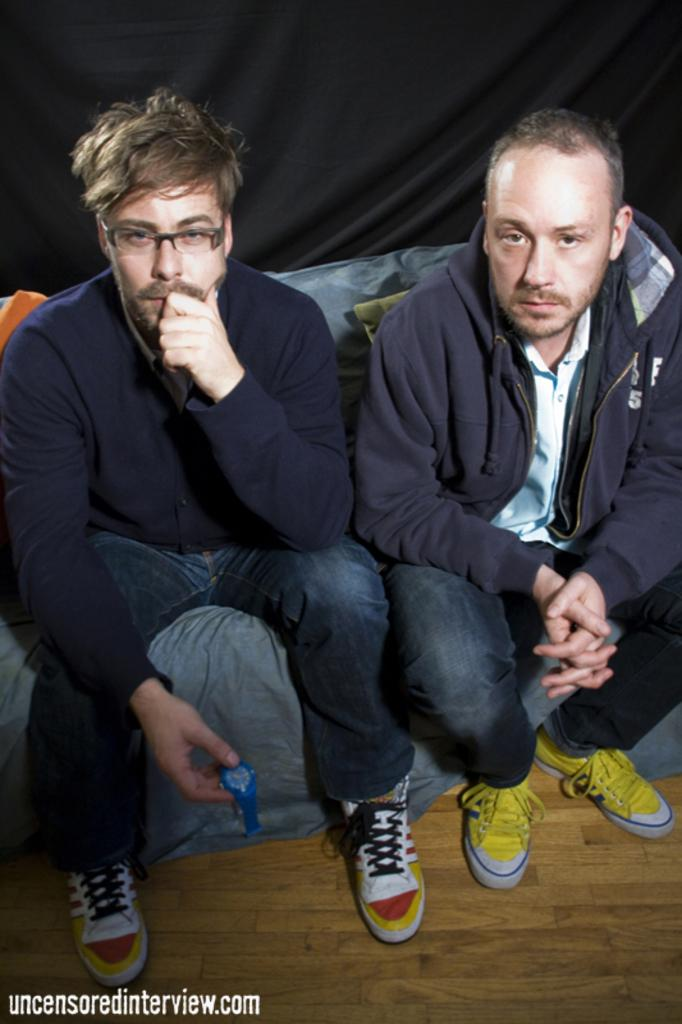How many people are in the foreground of the image? There are two men in the foreground of the image. What are the men doing in the image? The men are sitting on a couch in the image. What type of clothing are the men wearing? The men are wearing jackets in the image. What type of flooring is visible in the image? There is a wooden floor in the image. What can be seen in the background of the image? There is a black curtain in the background of the image. What type of snake can be seen slithering across the wooden floor in the image? There is no snake present in the image; it only features two men sitting on a couch. What type of produce is visible on the couch in the image? There is no produce visible on the couch or anywhere else in the image. 